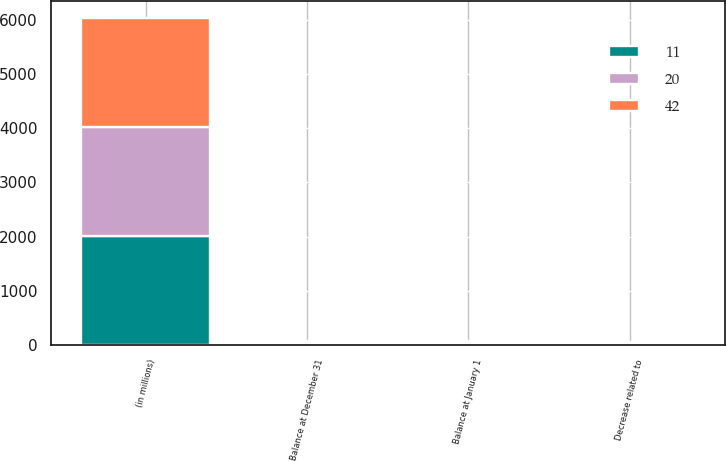Convert chart. <chart><loc_0><loc_0><loc_500><loc_500><stacked_bar_chart><ecel><fcel>(in millions)<fcel>Balance at January 1<fcel>Decrease related to<fcel>Balance at December 31<nl><fcel>11<fcel>2013<fcel>42<fcel>31<fcel>11<nl><fcel>20<fcel>2012<fcel>20<fcel>11<fcel>42<nl><fcel>42<fcel>2011<fcel>10<fcel>12<fcel>20<nl></chart> 